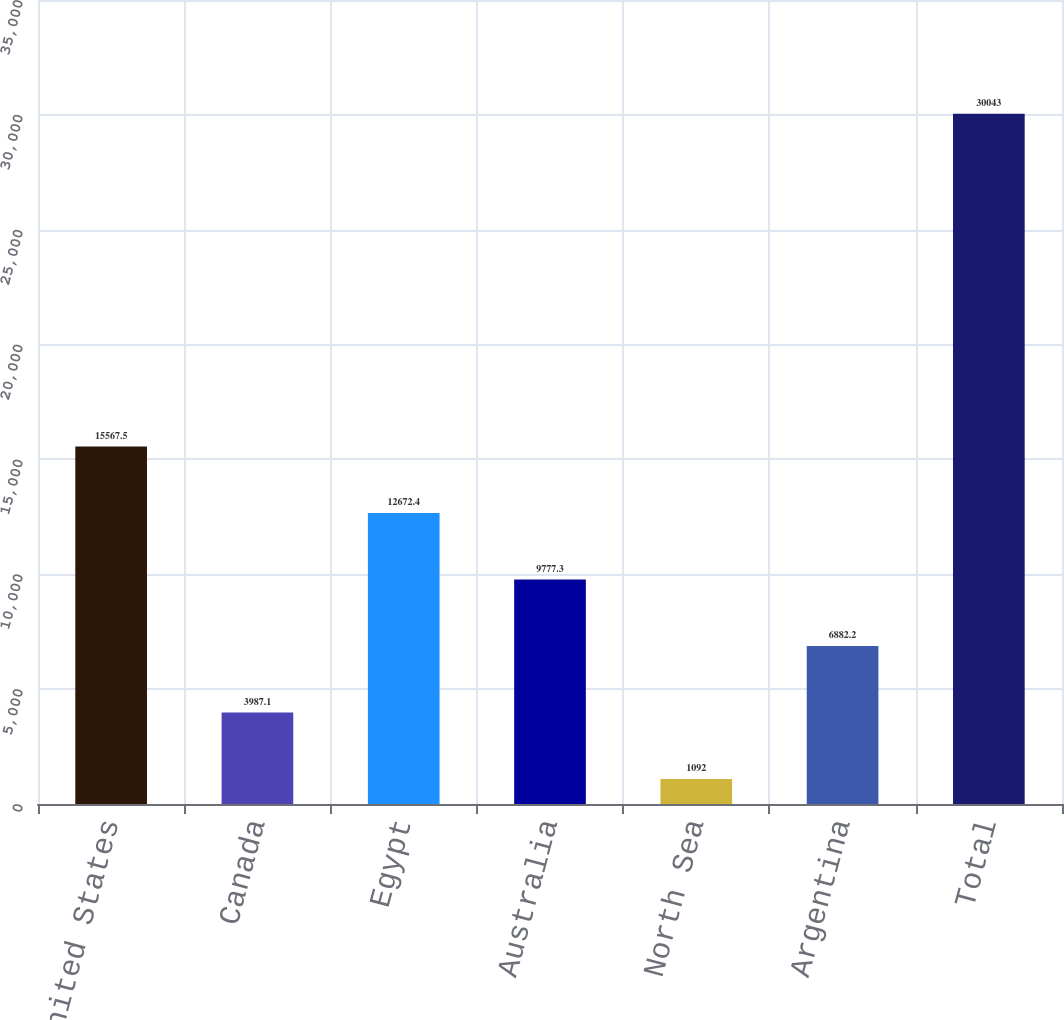Convert chart. <chart><loc_0><loc_0><loc_500><loc_500><bar_chart><fcel>United States<fcel>Canada<fcel>Egypt<fcel>Australia<fcel>North Sea<fcel>Argentina<fcel>Total<nl><fcel>15567.5<fcel>3987.1<fcel>12672.4<fcel>9777.3<fcel>1092<fcel>6882.2<fcel>30043<nl></chart> 